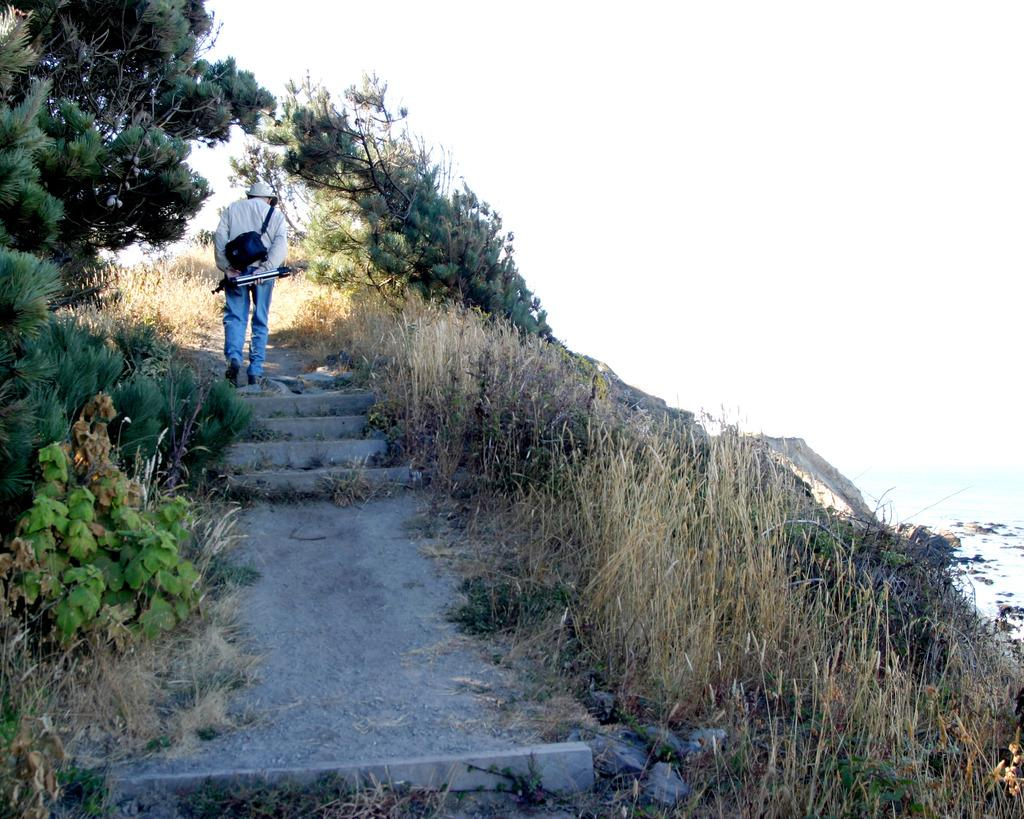What is the man in the image doing? The man is walking in the image. Where is the man located in the image? The man is walking in the middle of the image. What can be seen in the background of the image? There are trees in the image. What theory does the man have about the distance between the trees in the image? There is no indication in the image that the man has a theory about the distance between the trees, as the focus is on his action of walking. 